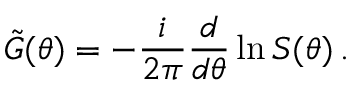<formula> <loc_0><loc_0><loc_500><loc_500>\tilde { G } ( \theta ) = - \frac { i } { 2 \pi } \frac { d } { d \theta } \ln S ( \theta ) \, .</formula> 